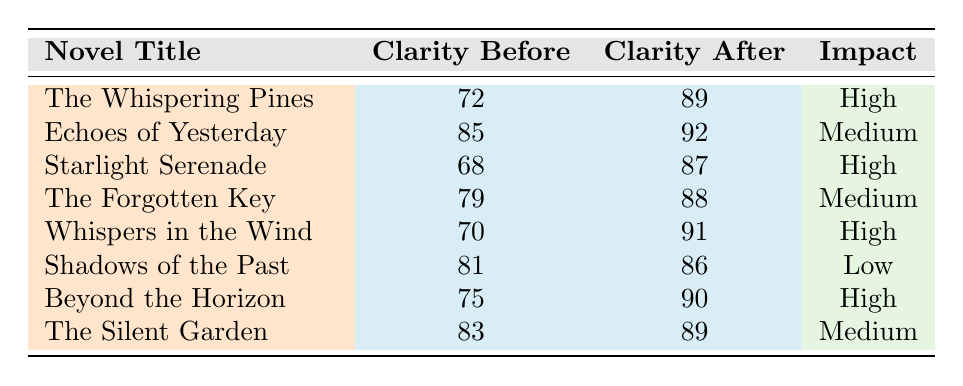What is the clarity score of "Whispers in the Wind" after maternal review? The table shows that the clarity score for "Whispers in the Wind" after maternal review is 91.
Answer: 91 What was the clarity score of "Shadows of the Past" before review? According to the table, the clarity score of "Shadows of the Past" before review was 81.
Answer: 81 How many novels received a "High" impact from maternal review? The table lists four novels with a "High" impact: "The Whispering Pines," "Starlight Serenade," "Whispers in the Wind," and "Beyond the Horizon."
Answer: 4 What is the difference in clarity score for "Echoes of Yesterday" before and after the review? The clarity score before was 85 and after was 92. The difference is 92 - 85 = 7.
Answer: 7 What is the average clarity score after maternal review of all novels? The clarity scores after review are 89, 92, 87, 88, 91, 86, 90, and 89. The sum is 712, and there are 8 novels, so the average is 712/8 = 89.
Answer: 89 Did any novel achieve a clarity score of 90 or higher after maternal review? Yes, the novels "Whispers in the Wind," "Beyond the Horizon," and "Echoes of Yesterday" achieved clarity scores of 90 or higher after review.
Answer: Yes Which genre of novel had the lowest clarity score before the review? The novel "Starlight Serenade" in the Romance genre had the lowest clarity score before the review at 68.
Answer: Romance What is the clarity score of "The Forgotten Key" before and after review and what is the impact rating? The clarity score before was 79, after was 88, and the impact rating is "Medium."
Answer: 79 before, 88 after, Medium impact How many novels improved their clarity score by more than 10 points after maternal review? The novels "Starlight Serenade," "Whispers in the Wind," and "Beyond the Horizon" improved by more than 10 points, specifically by 19, 21, and 15 points respectively.
Answer: 3 Is there any novel with a "Low" impact that improved its clarity score? Yes, "Shadows of the Past" had a "Low" impact but improved from 81 to 86.
Answer: Yes 